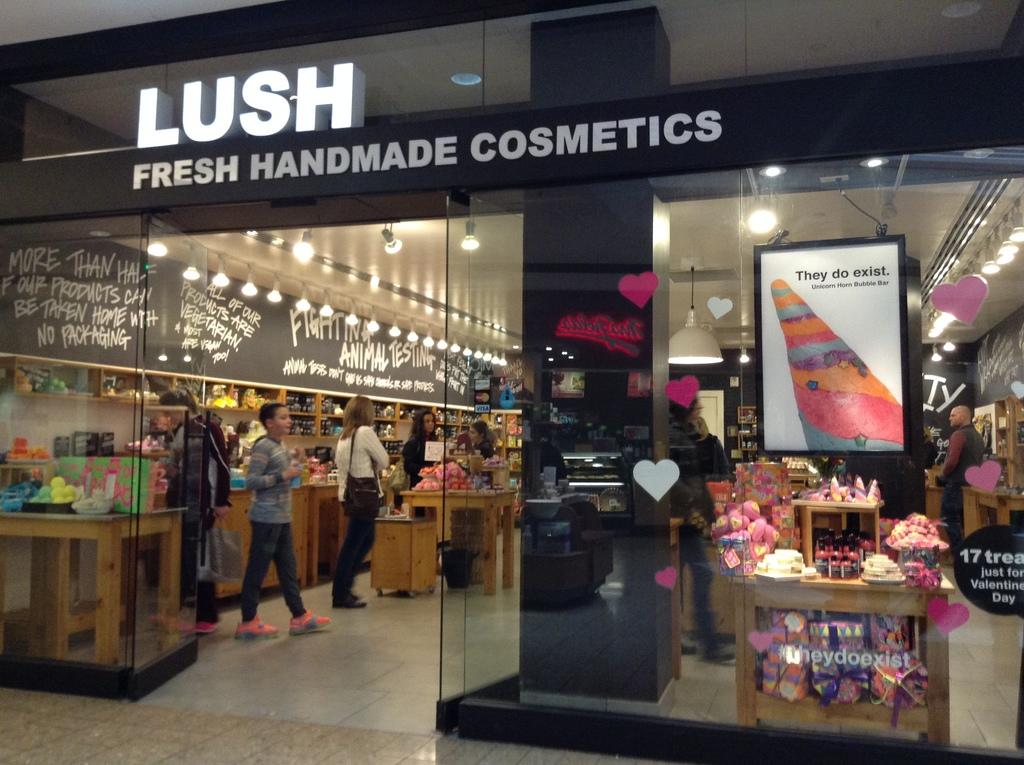Provide a one-sentence caption for the provided image. Customers are shopping in a beauty store named Lush. 